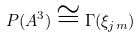<formula> <loc_0><loc_0><loc_500><loc_500>P ( A ^ { 3 } ) \cong \Gamma ( \xi _ { j m } )</formula> 